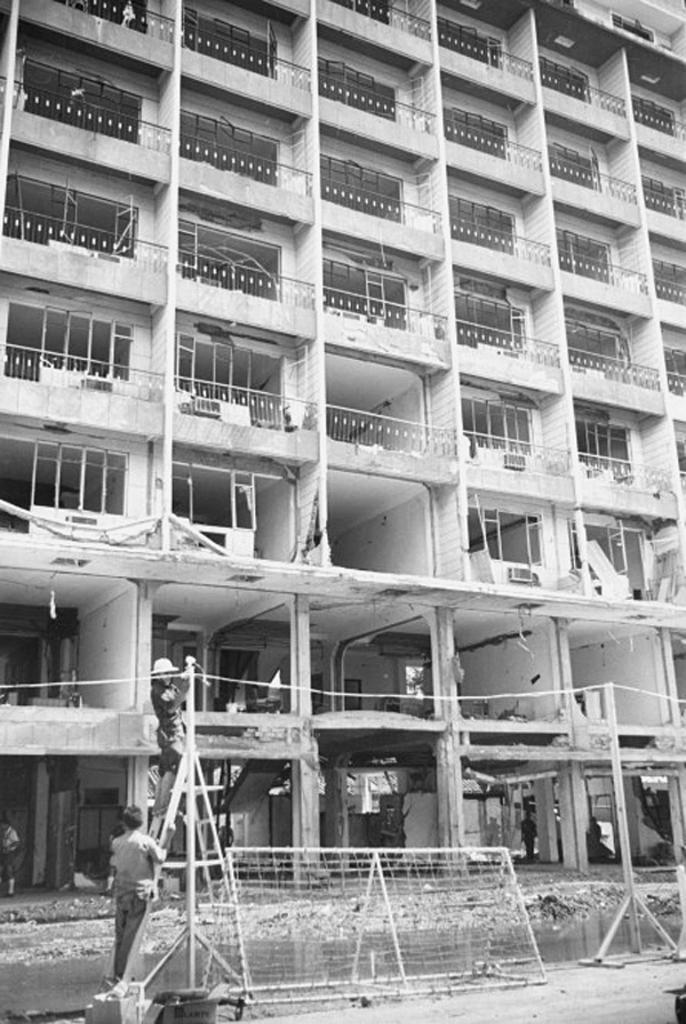Please provide a concise description of this image. In this image we can see building with windows, ladder, fence, stand and people. 